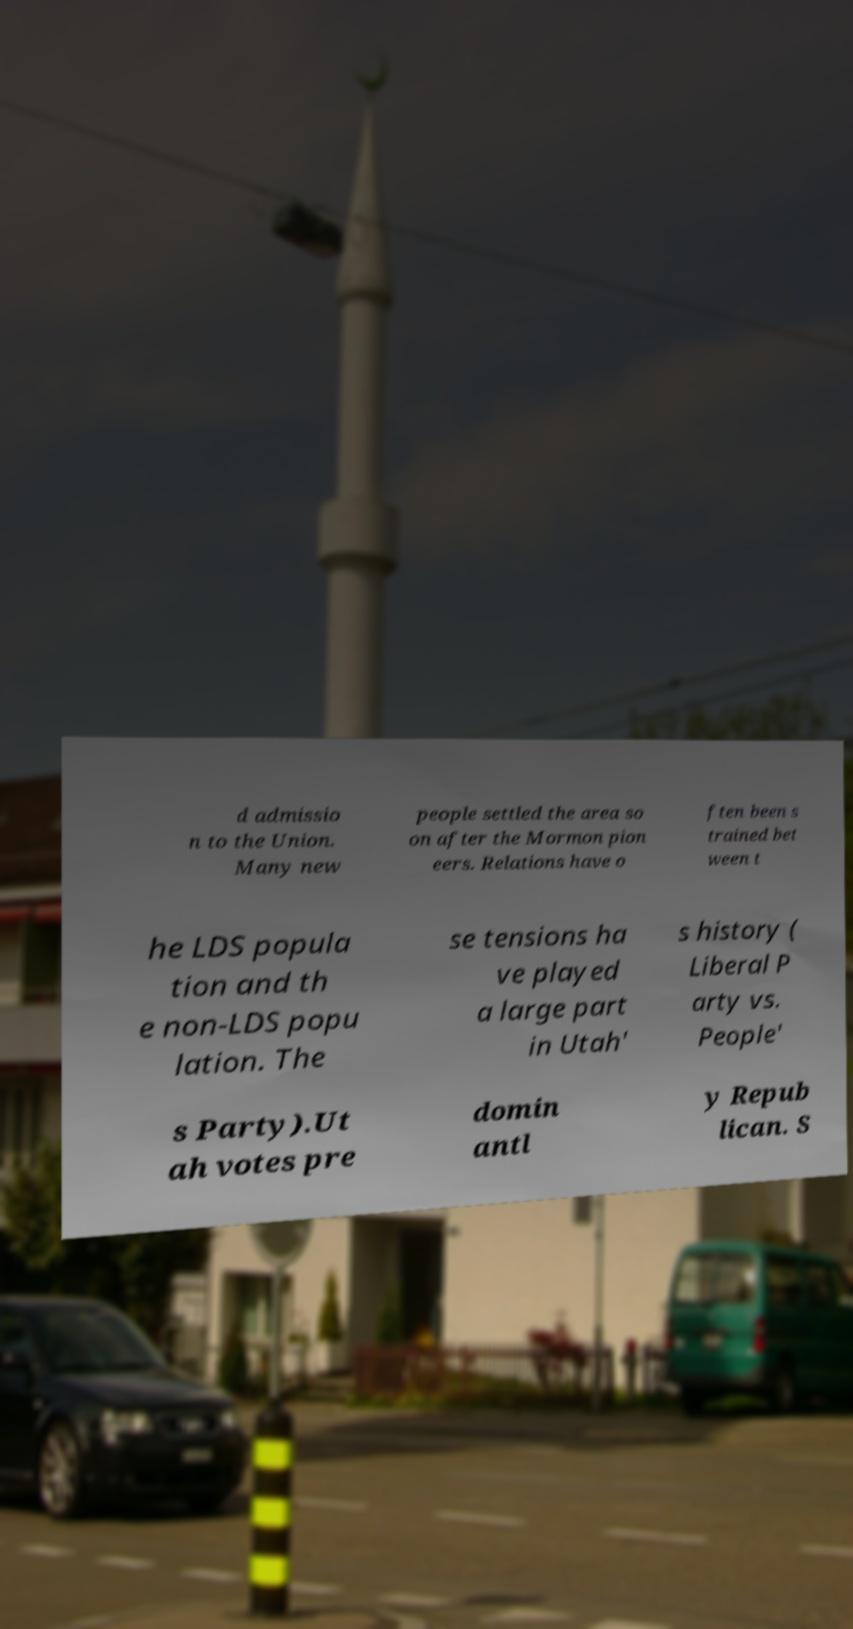Please identify and transcribe the text found in this image. d admissio n to the Union. Many new people settled the area so on after the Mormon pion eers. Relations have o ften been s trained bet ween t he LDS popula tion and th e non-LDS popu lation. The se tensions ha ve played a large part in Utah' s history ( Liberal P arty vs. People' s Party).Ut ah votes pre domin antl y Repub lican. S 